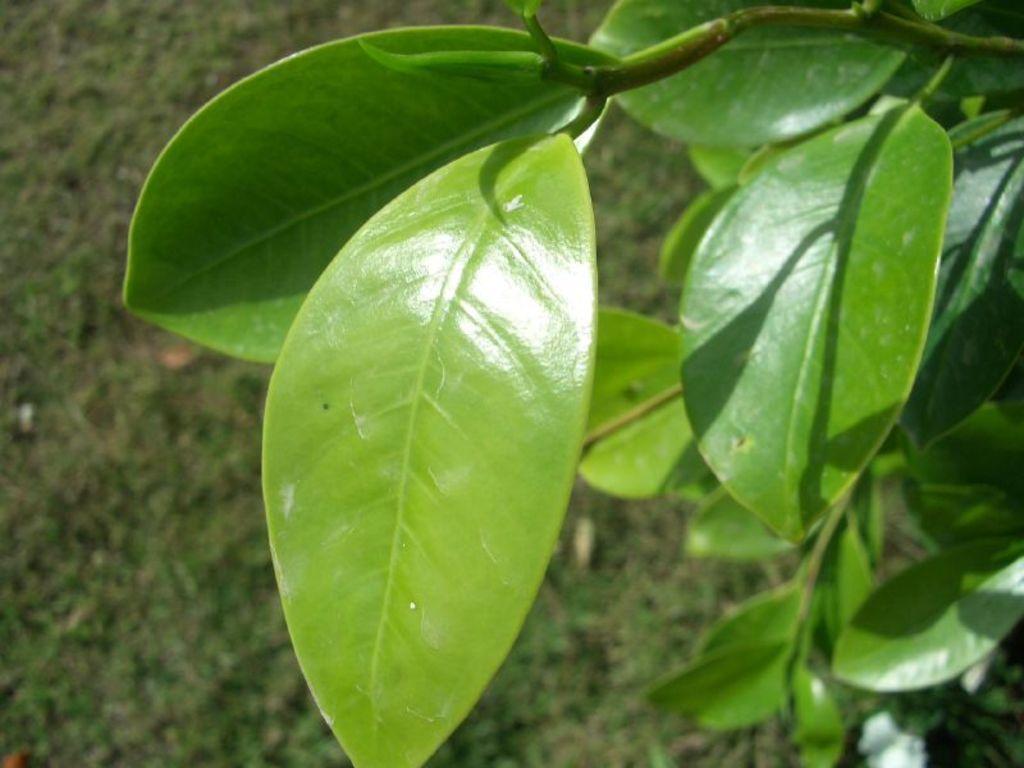Could you give a brief overview of what you see in this image? In this image I can see few green color leaves. Background is blurred. 